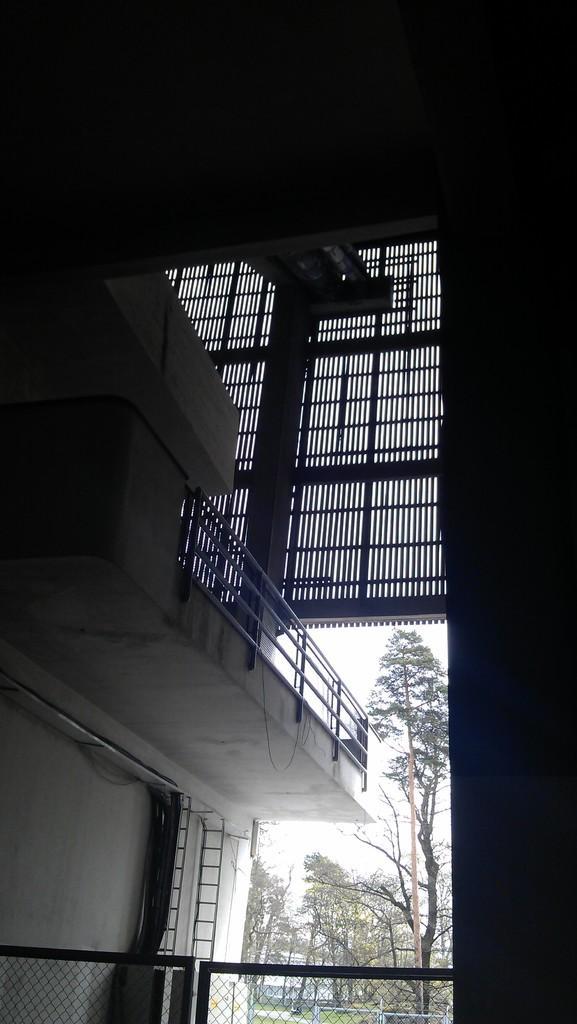Can you describe this image briefly? This image is clicked inside a building. At the bottom there is a fence. In the center there is a railing. Below to it there is an entrance. Outside the building there are trees and sky. 